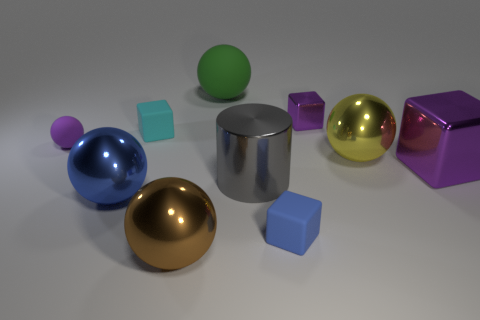Subtract all yellow balls. How many balls are left? 4 Subtract all small spheres. How many spheres are left? 4 Subtract all blue spheres. Subtract all cyan cubes. How many spheres are left? 4 Subtract all cubes. How many objects are left? 6 Add 9 big yellow things. How many big yellow things are left? 10 Add 8 tiny matte spheres. How many tiny matte spheres exist? 9 Subtract 0 brown cubes. How many objects are left? 10 Subtract all big green matte balls. Subtract all matte things. How many objects are left? 5 